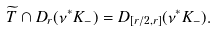<formula> <loc_0><loc_0><loc_500><loc_500>\widetilde { T } \cap D _ { r } ( \nu ^ { * } K _ { - } ) = D _ { [ r / 2 , r ] } ( \nu ^ { * } K _ { - } ) .</formula> 